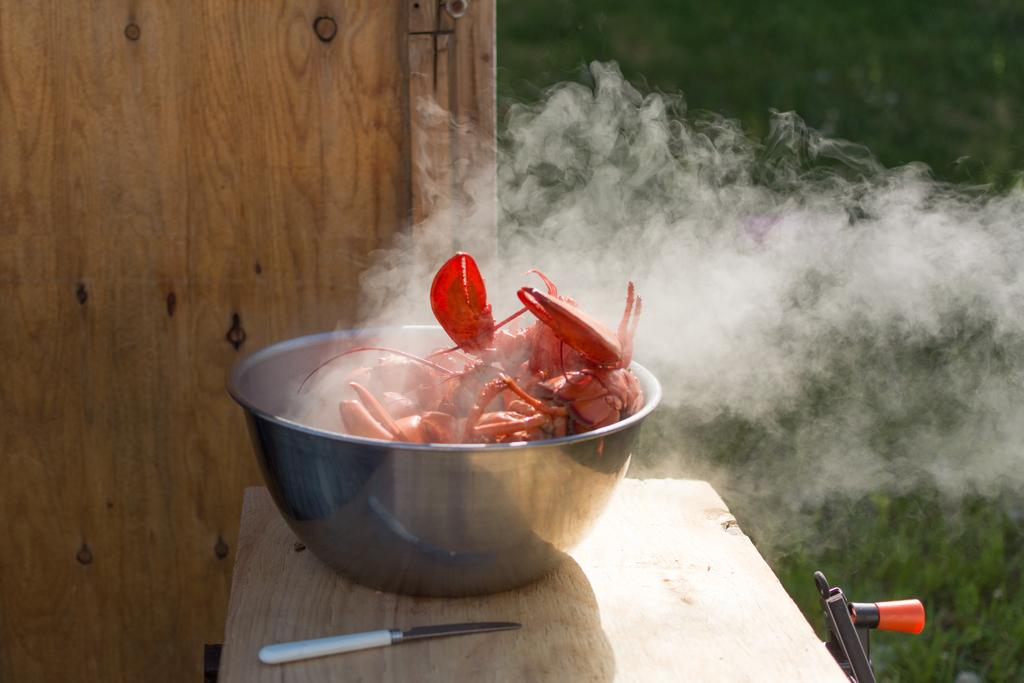What is in the bowl that is visible in the image? There is a bowl with food in the image. What utensil is present on a wooden platform in the image? A knife is present on a wooden platform in the image. What object can be seen in the image? There is an object in the image, but its specific nature is not mentioned in the provided facts. What is the nature of the smoke visible in the image? The facts do not provide any information about the nature of the smoke. What type of background is visible in the image? There is a wooden wall and grass in the background of the image. Where is the robin perched in the image? There is no robin present in the image. What type of curve can be seen in the image? The facts do not mention any curves in the image. 